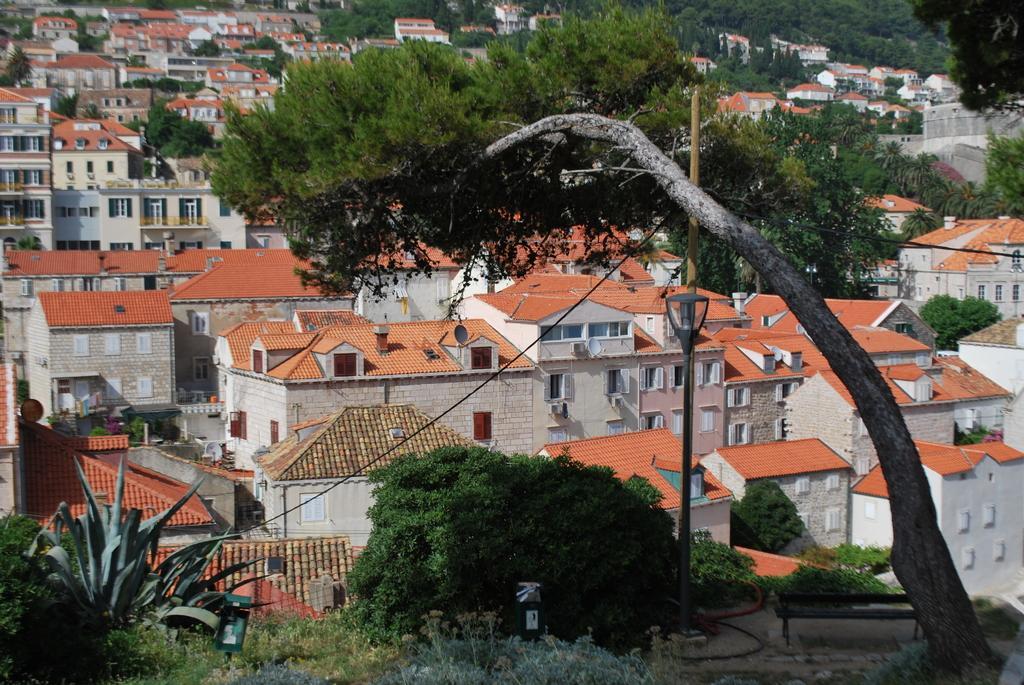Can you describe this image briefly? In this picture I can see there are buildings and trees, there are windows and doors to the buildings. 